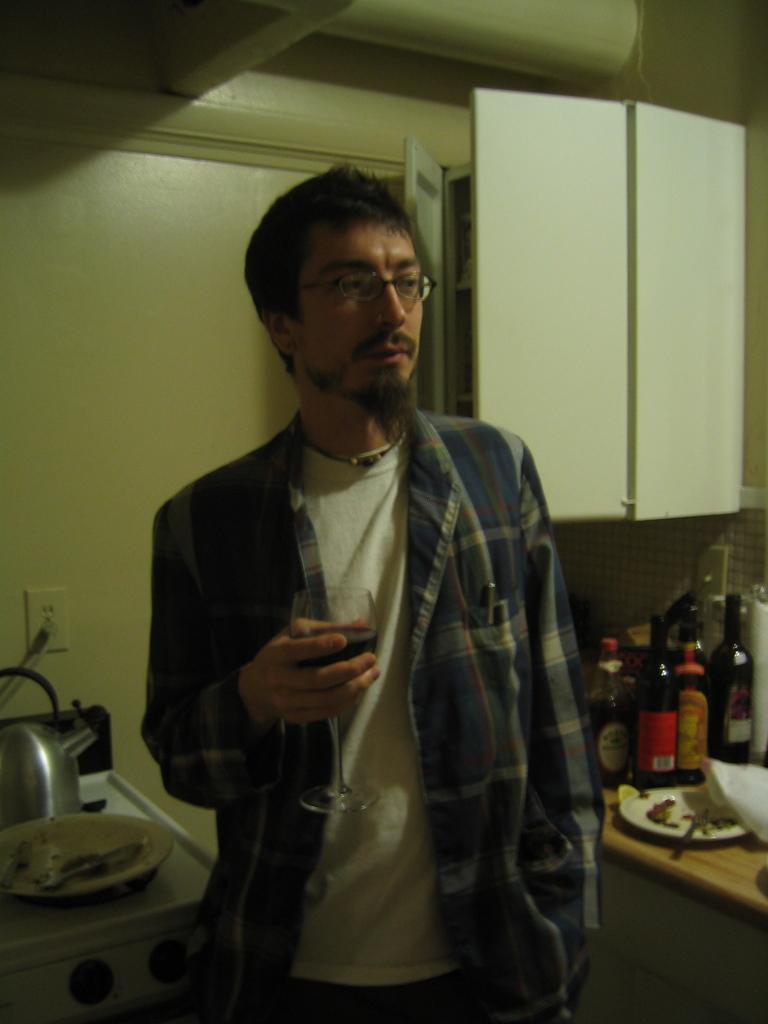Describe this image in one or two sentences. In a picture one person is standing in blue shirt and holding a wine glass and beside the person there is one table on the table there are some bottles and plate and there is one shelf and at the left side of the picture there is one gas stove and kettle on plate on it and behind him there is a wall. 